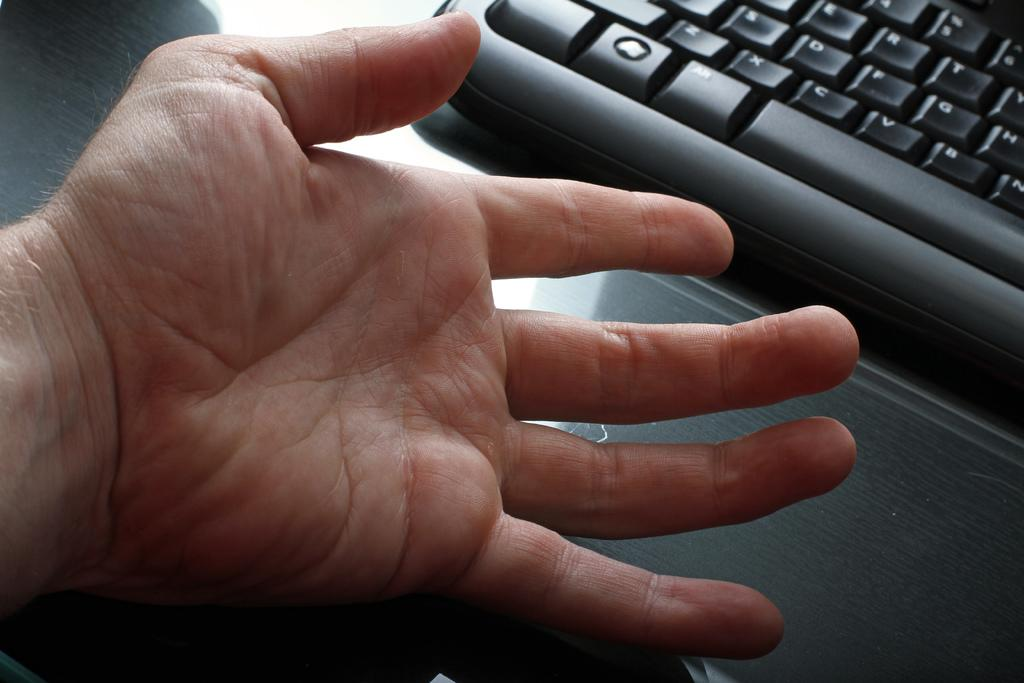<image>
Present a compact description of the photo's key features. A person's hand is in front of a keyboard with all of its keys including Alt. 